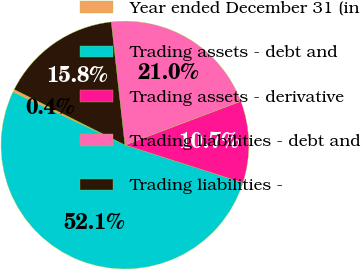Convert chart. <chart><loc_0><loc_0><loc_500><loc_500><pie_chart><fcel>Year ended December 31 (in<fcel>Trading assets - debt and<fcel>Trading assets - derivative<fcel>Trading liabilities - debt and<fcel>Trading liabilities -<nl><fcel>0.37%<fcel>52.1%<fcel>10.67%<fcel>21.02%<fcel>15.84%<nl></chart> 